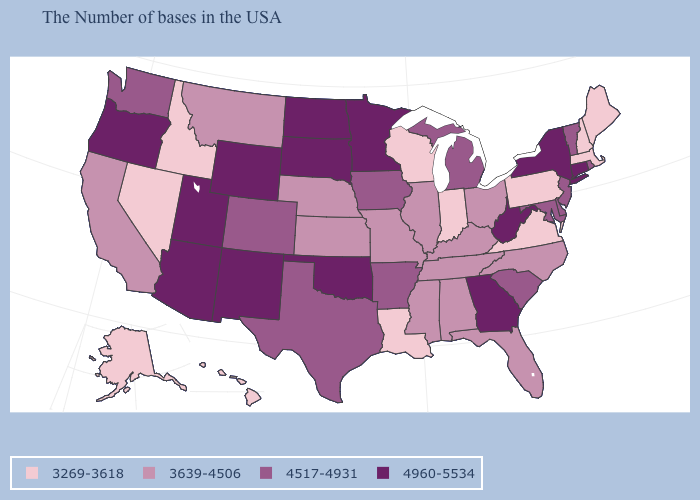Name the states that have a value in the range 4960-5534?
Quick response, please. Connecticut, New York, West Virginia, Georgia, Minnesota, Oklahoma, South Dakota, North Dakota, Wyoming, New Mexico, Utah, Arizona, Oregon. Name the states that have a value in the range 3269-3618?
Quick response, please. Maine, Massachusetts, New Hampshire, Pennsylvania, Virginia, Indiana, Wisconsin, Louisiana, Idaho, Nevada, Alaska, Hawaii. Does South Carolina have a lower value than West Virginia?
Keep it brief. Yes. Is the legend a continuous bar?
Keep it brief. No. Does Massachusetts have the lowest value in the USA?
Concise answer only. Yes. How many symbols are there in the legend?
Be succinct. 4. Which states have the highest value in the USA?
Keep it brief. Connecticut, New York, West Virginia, Georgia, Minnesota, Oklahoma, South Dakota, North Dakota, Wyoming, New Mexico, Utah, Arizona, Oregon. Name the states that have a value in the range 4960-5534?
Concise answer only. Connecticut, New York, West Virginia, Georgia, Minnesota, Oklahoma, South Dakota, North Dakota, Wyoming, New Mexico, Utah, Arizona, Oregon. Name the states that have a value in the range 3269-3618?
Be succinct. Maine, Massachusetts, New Hampshire, Pennsylvania, Virginia, Indiana, Wisconsin, Louisiana, Idaho, Nevada, Alaska, Hawaii. Among the states that border Tennessee , which have the highest value?
Keep it brief. Georgia. What is the lowest value in the USA?
Answer briefly. 3269-3618. What is the value of Indiana?
Answer briefly. 3269-3618. Among the states that border Massachusetts , does Vermont have the highest value?
Give a very brief answer. No. Which states have the lowest value in the USA?
Write a very short answer. Maine, Massachusetts, New Hampshire, Pennsylvania, Virginia, Indiana, Wisconsin, Louisiana, Idaho, Nevada, Alaska, Hawaii. Is the legend a continuous bar?
Answer briefly. No. 